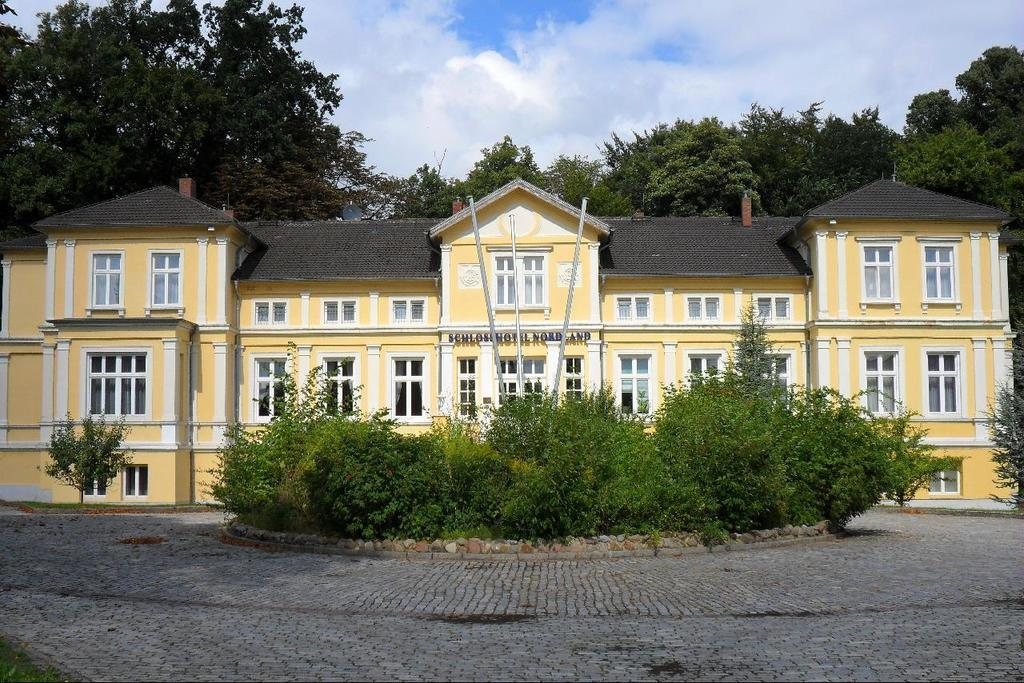What type of structure is present in the image? There is a building in the image. What natural elements can be seen in the image? There are trees and plants visible in the image. What man-made objects are present in the image? There are poles in the image. What is the surface on which the building and other objects are placed? There is a ground visible in the image. What can be seen in the sky in the image? There are clouds in the sky in the image. What type of canvas is being used to paint the building in the image? There is no canvas or painting activity present in the image; it is a photograph of a building, trees, plants, poles, and clouds. Can you tell me how many brains are visible in the image? There are no brains visible in the image; it features a building, trees, plants, poles, and clouds. 